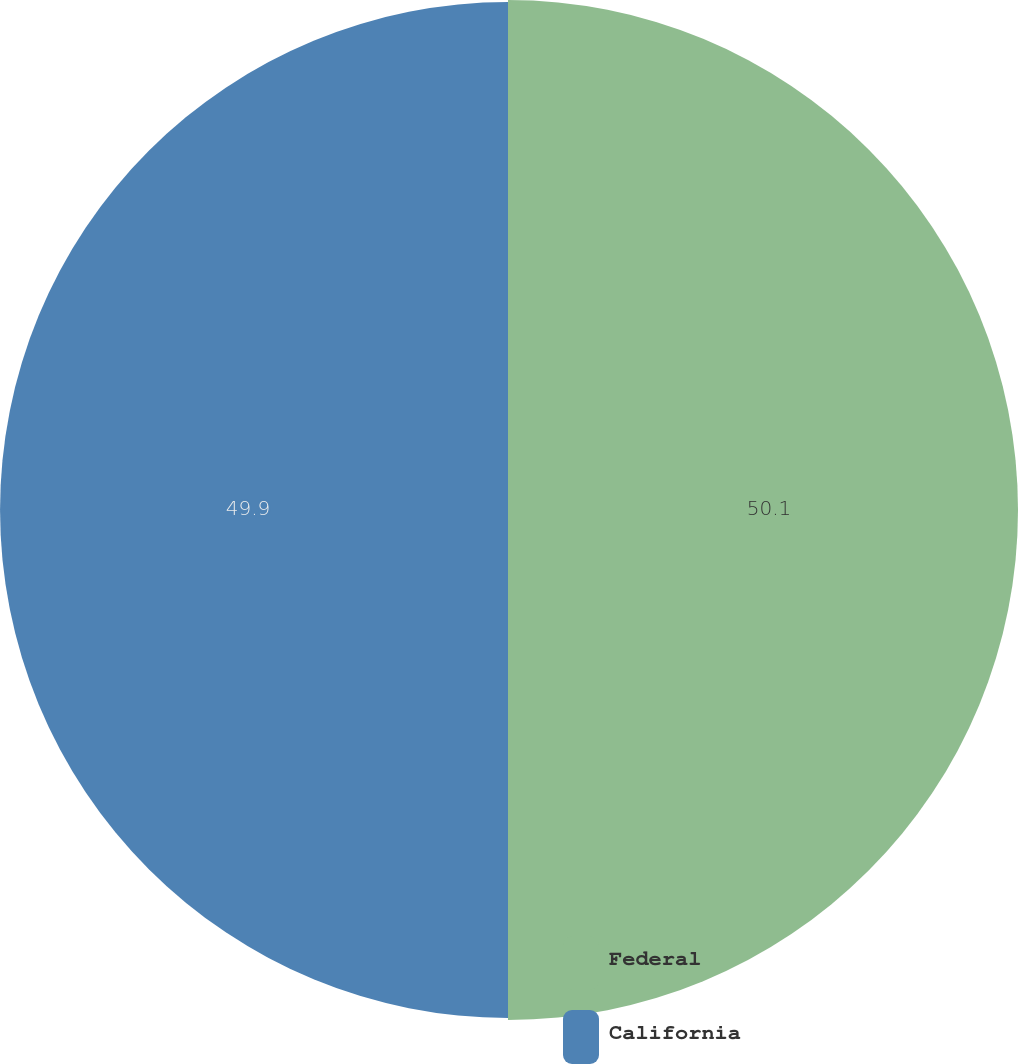Convert chart. <chart><loc_0><loc_0><loc_500><loc_500><pie_chart><fcel>Federal<fcel>California<nl><fcel>50.1%<fcel>49.9%<nl></chart> 